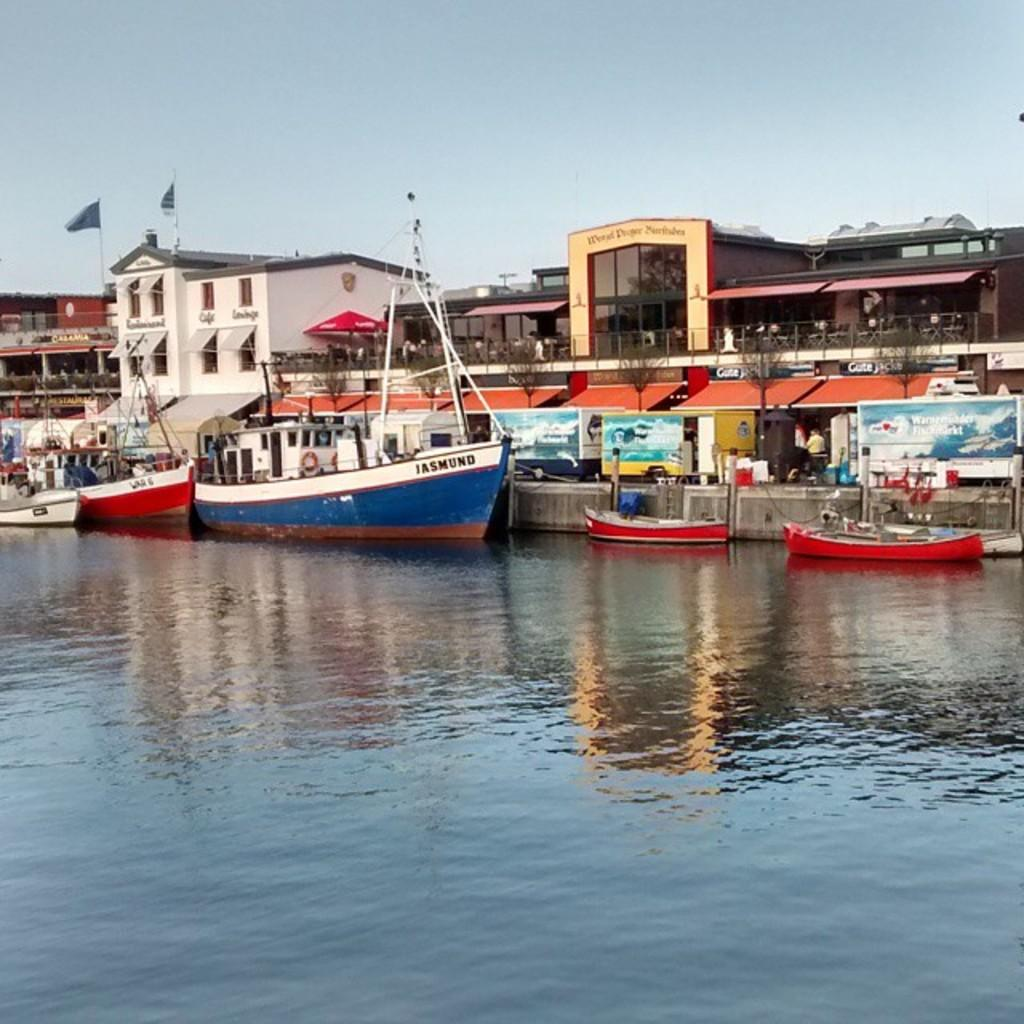What is on the water in the image? There are boats on the water in the image. What types of transportation can be seen in the image? There are vehicles in the image. What structures are present in the image? There are buildings in the image. What decorative or symbolic items are visible in the image? There are flags in the image. What type of vegetation is present in the image? There are trees in the image. What objects are used for displaying information or advertisements in the image? There are boards in the image. What type of shelter is present in the image? There is an umbrella in the image. What part of the natural environment is visible in the background of the image? The sky is visible in the background of the image. How many crates are stacked next to the trees in the image? There are no crates present in the image. What do the visitors think about the boats in the image? There is no indication of any visitors in the image, so their thoughts cannot be determined. 